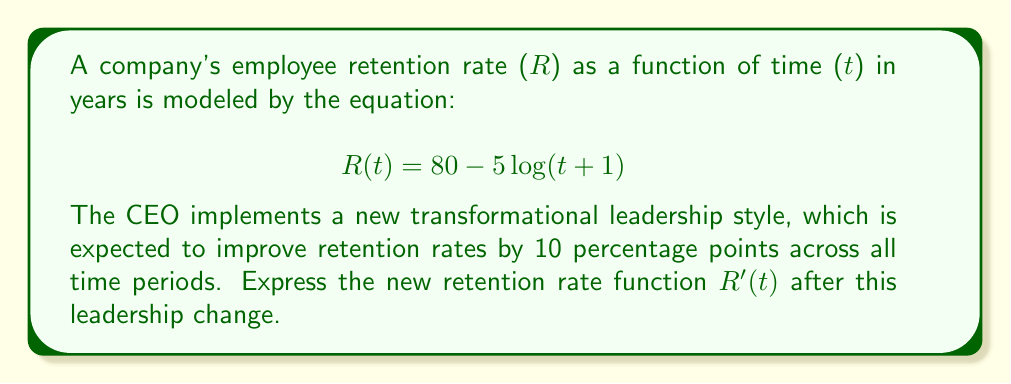Can you answer this question? To solve this problem, we need to understand how function translations work and apply them to the given scenario:

1. The original function is $$R(t) = 80 - 5\log(t+1)$$

2. The new leadership style is expected to improve retention rates by 10 percentage points across all time periods. This means we need to shift the entire function upward by 10 units.

3. In function transformation terms, this is a vertical translation upward by 10 units. The general form of a vertical translation is:

   $$f(x) \rightarrow f(x) + k$$

   where $k$ is positive for upward shifts and negative for downward shifts.

4. In our case, $k = 10$, so we add 10 to the original function:

   $$R'(t) = R(t) + 10$$

5. Substituting the original function:

   $$R'(t) = [80 - 5\log(t+1)] + 10$$

6. Simplifying:

   $$R'(t) = 90 - 5\log(t+1)$$

This new function R'(t) represents the retention rate after the implementation of the new leadership style, shifted upward by 10 percentage points for all values of t.
Answer: $$R'(t) = 90 - 5\log(t+1)$$ 